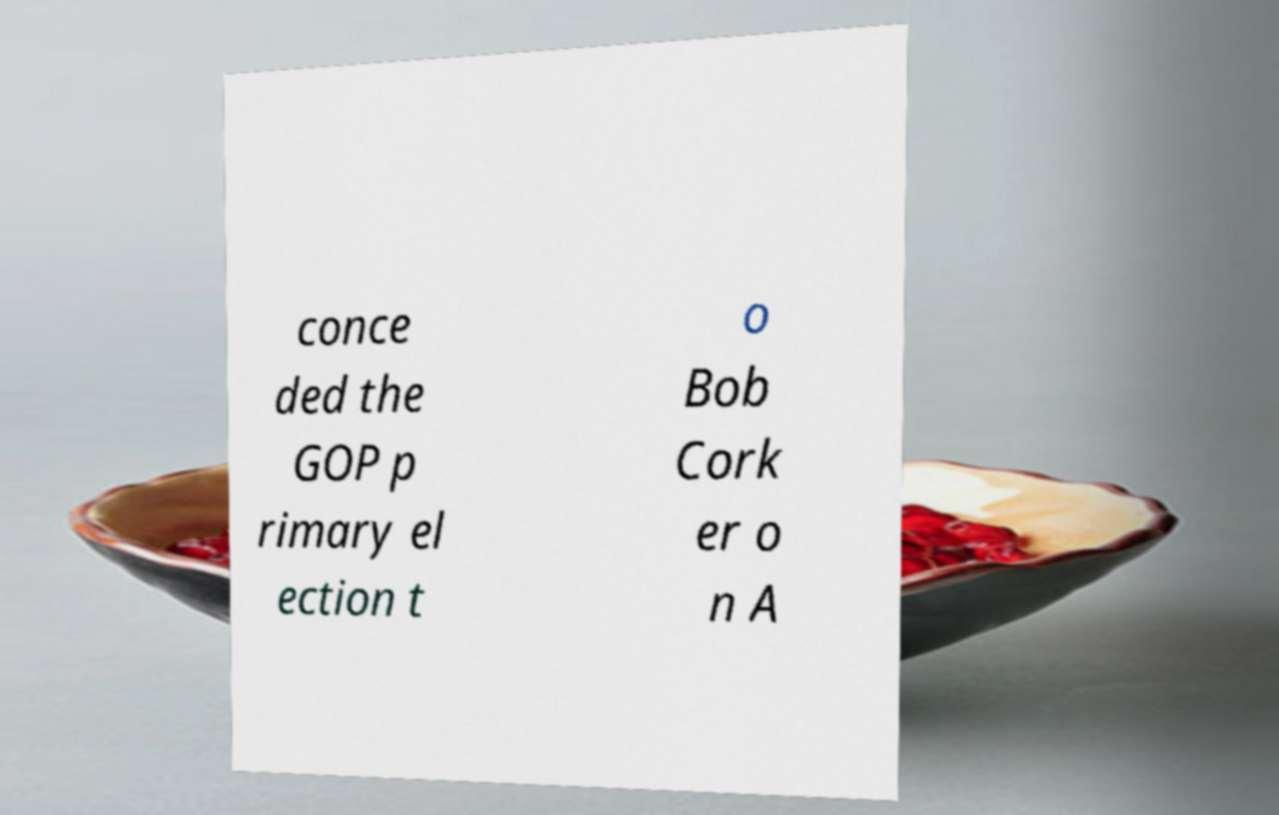Please identify and transcribe the text found in this image. conce ded the GOP p rimary el ection t o Bob Cork er o n A 